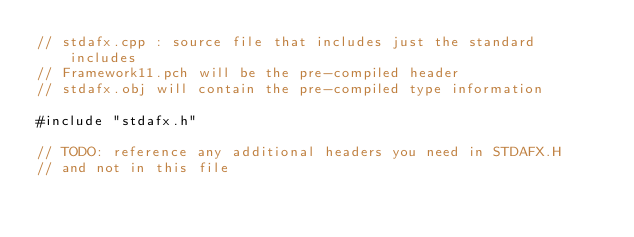<code> <loc_0><loc_0><loc_500><loc_500><_C++_>// stdafx.cpp : source file that includes just the standard includes
// Framework11.pch will be the pre-compiled header
// stdafx.obj will contain the pre-compiled type information

#include "stdafx.h"

// TODO: reference any additional headers you need in STDAFX.H
// and not in this file
</code> 